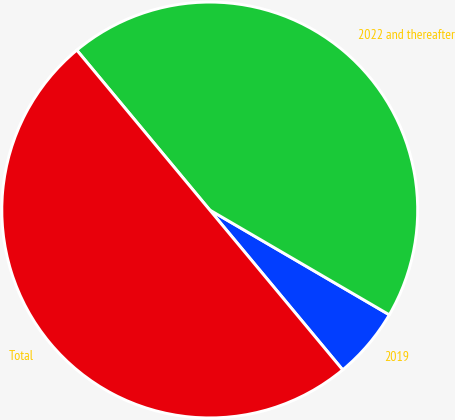Convert chart. <chart><loc_0><loc_0><loc_500><loc_500><pie_chart><fcel>2019<fcel>2022 and thereafter<fcel>Total<nl><fcel>5.55%<fcel>44.45%<fcel>50.0%<nl></chart> 